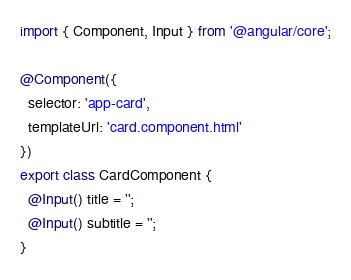<code> <loc_0><loc_0><loc_500><loc_500><_TypeScript_>import { Component, Input } from '@angular/core';

@Component({
  selector: 'app-card',
  templateUrl: 'card.component.html'
})
export class CardComponent {
  @Input() title = '';
  @Input() subtitle = '';
}
</code> 